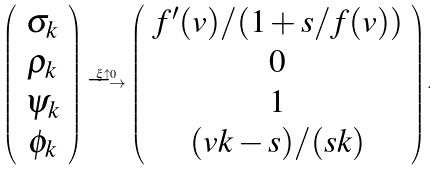<formula> <loc_0><loc_0><loc_500><loc_500>\left ( \begin{array} { c } \sigma _ { k } \\ \rho _ { k } \\ \psi _ { k } \\ \phi _ { k } \end{array} \right ) \stackrel { \xi \uparrow 0 } { \longrightarrow } \left ( \begin{array} { c } f ^ { \prime } ( v ) / ( 1 + s / f ( v ) ) \\ 0 \\ 1 \\ ( v k - s ) / ( s k ) \end{array} \right ) .</formula> 